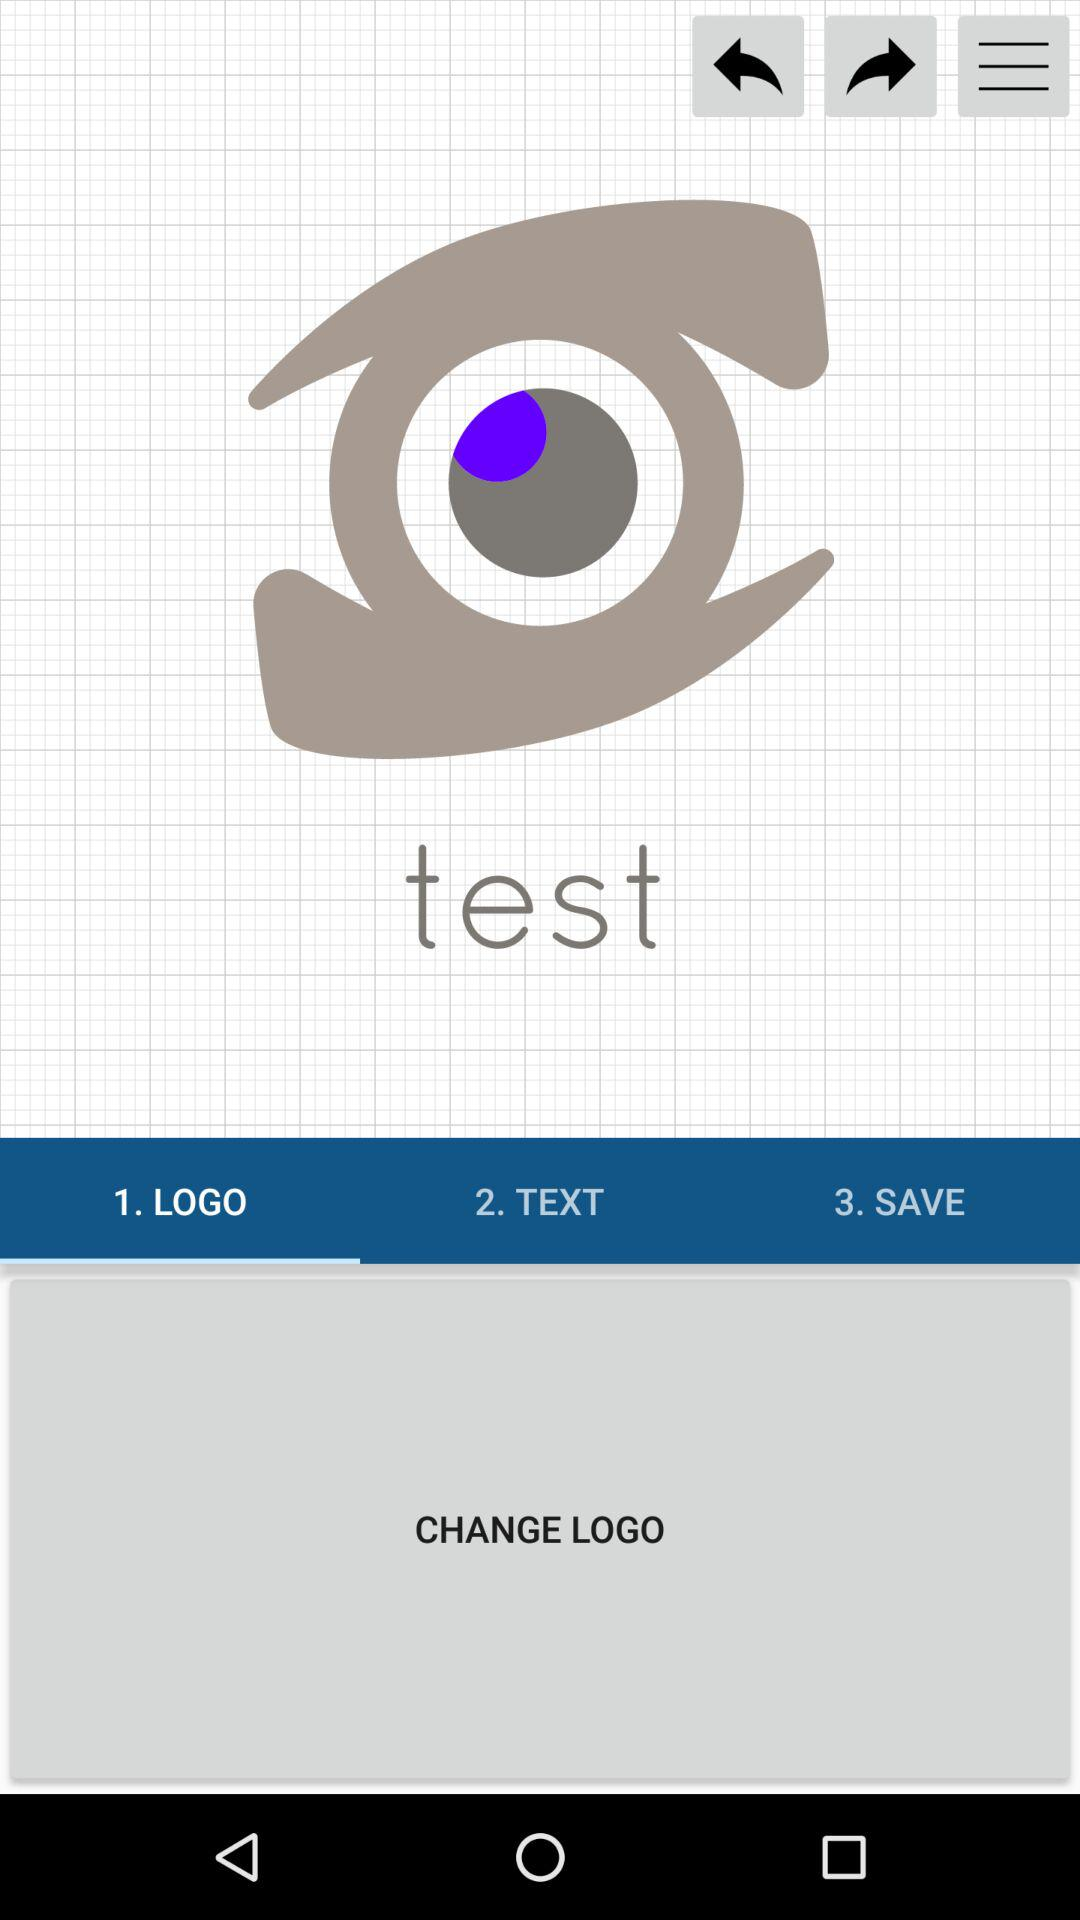What is the selected tab? The selected tab is "1. LOGO". 